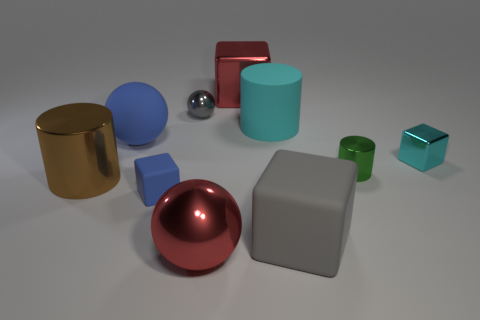Subtract all spheres. How many objects are left? 7 Subtract 1 brown cylinders. How many objects are left? 9 Subtract all big gray spheres. Subtract all metallic things. How many objects are left? 4 Add 3 tiny metal balls. How many tiny metal balls are left? 4 Add 2 blue things. How many blue things exist? 4 